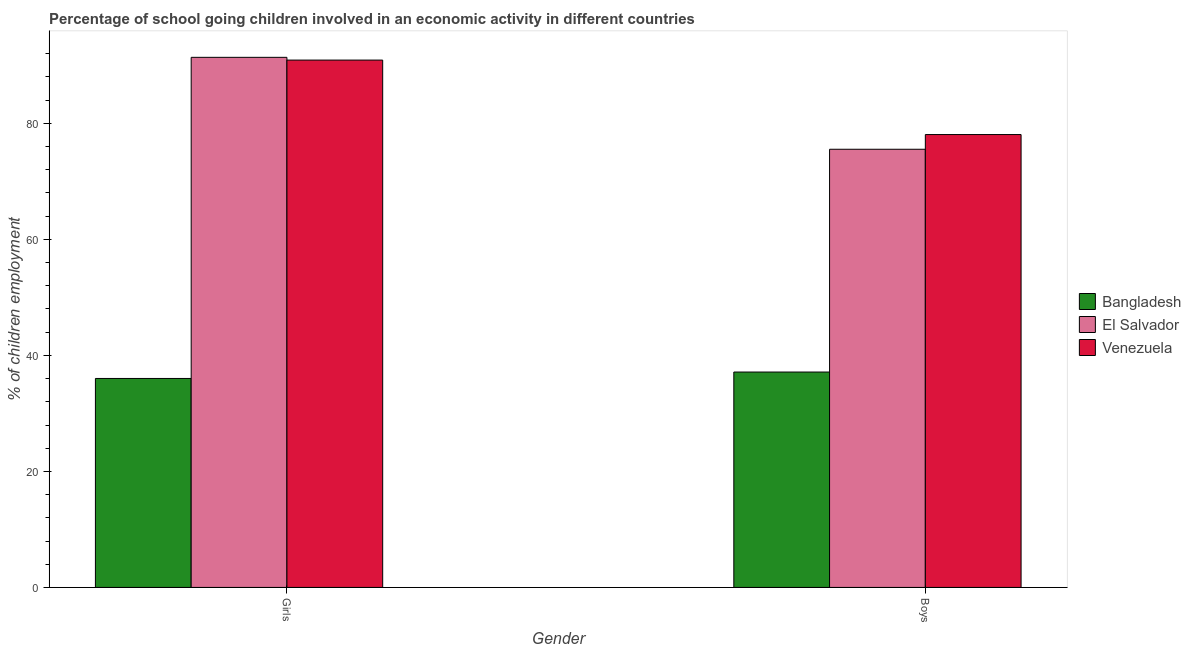How many groups of bars are there?
Give a very brief answer. 2. Are the number of bars per tick equal to the number of legend labels?
Provide a short and direct response. Yes. What is the label of the 2nd group of bars from the left?
Provide a short and direct response. Boys. What is the percentage of school going girls in Venezuela?
Offer a terse response. 90.91. Across all countries, what is the maximum percentage of school going girls?
Ensure brevity in your answer.  91.38. Across all countries, what is the minimum percentage of school going girls?
Ensure brevity in your answer.  36.02. In which country was the percentage of school going girls maximum?
Your answer should be very brief. El Salvador. What is the total percentage of school going boys in the graph?
Provide a short and direct response. 190.73. What is the difference between the percentage of school going girls in El Salvador and that in Venezuela?
Make the answer very short. 0.47. What is the difference between the percentage of school going girls in Venezuela and the percentage of school going boys in Bangladesh?
Your answer should be very brief. 53.78. What is the average percentage of school going girls per country?
Keep it short and to the point. 72.77. What is the difference between the percentage of school going boys and percentage of school going girls in Venezuela?
Your response must be concise. -12.84. In how many countries, is the percentage of school going boys greater than 20 %?
Give a very brief answer. 3. What is the ratio of the percentage of school going girls in Venezuela to that in El Salvador?
Ensure brevity in your answer.  0.99. Is the percentage of school going boys in El Salvador less than that in Bangladesh?
Provide a short and direct response. No. What does the 3rd bar from the left in Boys represents?
Provide a succinct answer. Venezuela. What does the 2nd bar from the right in Girls represents?
Offer a terse response. El Salvador. What is the difference between two consecutive major ticks on the Y-axis?
Offer a very short reply. 20. Are the values on the major ticks of Y-axis written in scientific E-notation?
Your answer should be compact. No. Does the graph contain any zero values?
Offer a very short reply. No. Does the graph contain grids?
Keep it short and to the point. No. How are the legend labels stacked?
Ensure brevity in your answer.  Vertical. What is the title of the graph?
Ensure brevity in your answer.  Percentage of school going children involved in an economic activity in different countries. Does "Peru" appear as one of the legend labels in the graph?
Offer a very short reply. No. What is the label or title of the Y-axis?
Provide a short and direct response. % of children employment. What is the % of children employment in Bangladesh in Girls?
Ensure brevity in your answer.  36.02. What is the % of children employment in El Salvador in Girls?
Keep it short and to the point. 91.38. What is the % of children employment in Venezuela in Girls?
Give a very brief answer. 90.91. What is the % of children employment in Bangladesh in Boys?
Keep it short and to the point. 37.13. What is the % of children employment of El Salvador in Boys?
Keep it short and to the point. 75.53. What is the % of children employment of Venezuela in Boys?
Your response must be concise. 78.07. Across all Gender, what is the maximum % of children employment of Bangladesh?
Your answer should be very brief. 37.13. Across all Gender, what is the maximum % of children employment in El Salvador?
Keep it short and to the point. 91.38. Across all Gender, what is the maximum % of children employment of Venezuela?
Provide a succinct answer. 90.91. Across all Gender, what is the minimum % of children employment in Bangladesh?
Your answer should be compact. 36.02. Across all Gender, what is the minimum % of children employment in El Salvador?
Give a very brief answer. 75.53. Across all Gender, what is the minimum % of children employment of Venezuela?
Give a very brief answer. 78.07. What is the total % of children employment of Bangladesh in the graph?
Provide a short and direct response. 73.15. What is the total % of children employment in El Salvador in the graph?
Ensure brevity in your answer.  166.92. What is the total % of children employment in Venezuela in the graph?
Offer a terse response. 168.98. What is the difference between the % of children employment in Bangladesh in Girls and that in Boys?
Offer a very short reply. -1.11. What is the difference between the % of children employment of El Salvador in Girls and that in Boys?
Offer a terse response. 15.85. What is the difference between the % of children employment in Venezuela in Girls and that in Boys?
Offer a terse response. 12.84. What is the difference between the % of children employment of Bangladesh in Girls and the % of children employment of El Salvador in Boys?
Offer a very short reply. -39.51. What is the difference between the % of children employment in Bangladesh in Girls and the % of children employment in Venezuela in Boys?
Ensure brevity in your answer.  -42.05. What is the difference between the % of children employment of El Salvador in Girls and the % of children employment of Venezuela in Boys?
Make the answer very short. 13.31. What is the average % of children employment of Bangladesh per Gender?
Your answer should be very brief. 36.58. What is the average % of children employment in El Salvador per Gender?
Give a very brief answer. 83.46. What is the average % of children employment of Venezuela per Gender?
Provide a short and direct response. 84.49. What is the difference between the % of children employment of Bangladesh and % of children employment of El Salvador in Girls?
Give a very brief answer. -55.36. What is the difference between the % of children employment in Bangladesh and % of children employment in Venezuela in Girls?
Your response must be concise. -54.88. What is the difference between the % of children employment in El Salvador and % of children employment in Venezuela in Girls?
Ensure brevity in your answer.  0.47. What is the difference between the % of children employment in Bangladesh and % of children employment in El Salvador in Boys?
Make the answer very short. -38.4. What is the difference between the % of children employment of Bangladesh and % of children employment of Venezuela in Boys?
Your answer should be very brief. -40.94. What is the difference between the % of children employment of El Salvador and % of children employment of Venezuela in Boys?
Provide a succinct answer. -2.54. What is the ratio of the % of children employment in Bangladesh in Girls to that in Boys?
Keep it short and to the point. 0.97. What is the ratio of the % of children employment in El Salvador in Girls to that in Boys?
Your answer should be very brief. 1.21. What is the ratio of the % of children employment of Venezuela in Girls to that in Boys?
Provide a succinct answer. 1.16. What is the difference between the highest and the second highest % of children employment of Bangladesh?
Your response must be concise. 1.11. What is the difference between the highest and the second highest % of children employment in El Salvador?
Give a very brief answer. 15.85. What is the difference between the highest and the second highest % of children employment of Venezuela?
Ensure brevity in your answer.  12.84. What is the difference between the highest and the lowest % of children employment in Bangladesh?
Provide a short and direct response. 1.11. What is the difference between the highest and the lowest % of children employment in El Salvador?
Keep it short and to the point. 15.85. What is the difference between the highest and the lowest % of children employment in Venezuela?
Offer a very short reply. 12.84. 